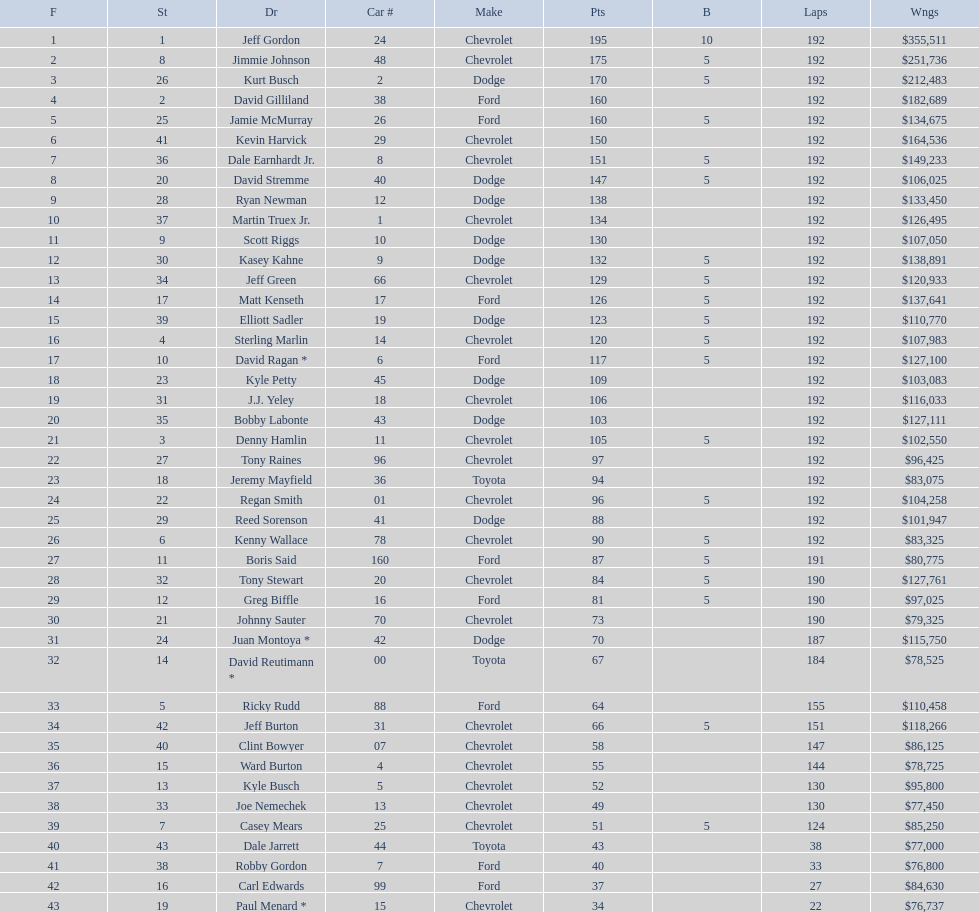How many drivers earned 5 bonus each in the race? 19. 